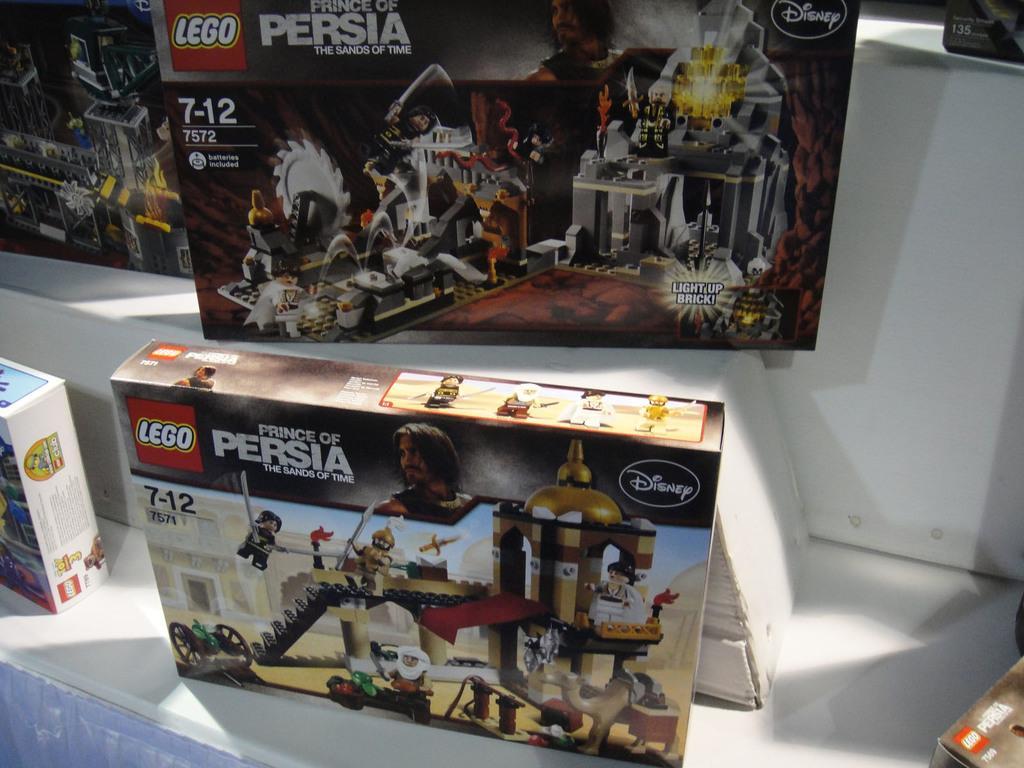In one or two sentences, can you explain what this image depicts? In this picture I can see the boxes. I can see toy pictures on the box. 